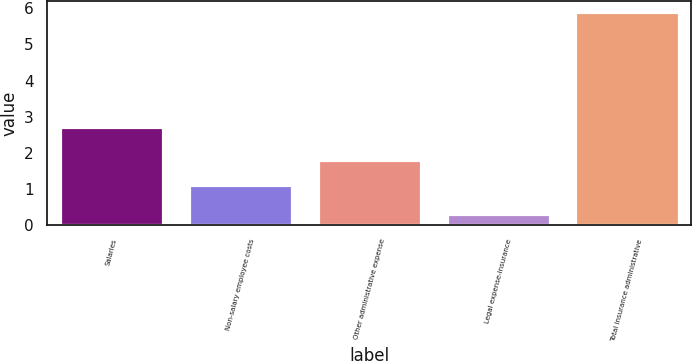<chart> <loc_0><loc_0><loc_500><loc_500><bar_chart><fcel>Salaries<fcel>Non-salary employee costs<fcel>Other administrative expense<fcel>Legal expense-insurance<fcel>Total insurance administrative<nl><fcel>2.7<fcel>1.1<fcel>1.8<fcel>0.3<fcel>5.9<nl></chart> 